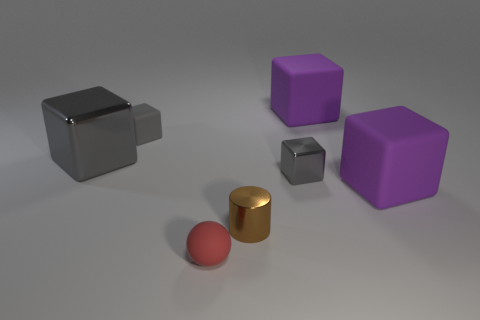Subtract all red cylinders. How many gray blocks are left? 3 Subtract all tiny rubber cubes. How many cubes are left? 4 Subtract all cyan blocks. Subtract all blue cylinders. How many blocks are left? 5 Add 3 small gray cylinders. How many objects exist? 10 Subtract all cylinders. How many objects are left? 6 Add 7 tiny blocks. How many tiny blocks exist? 9 Subtract 0 blue cylinders. How many objects are left? 7 Subtract all tiny blue balls. Subtract all matte objects. How many objects are left? 3 Add 2 shiny cubes. How many shiny cubes are left? 4 